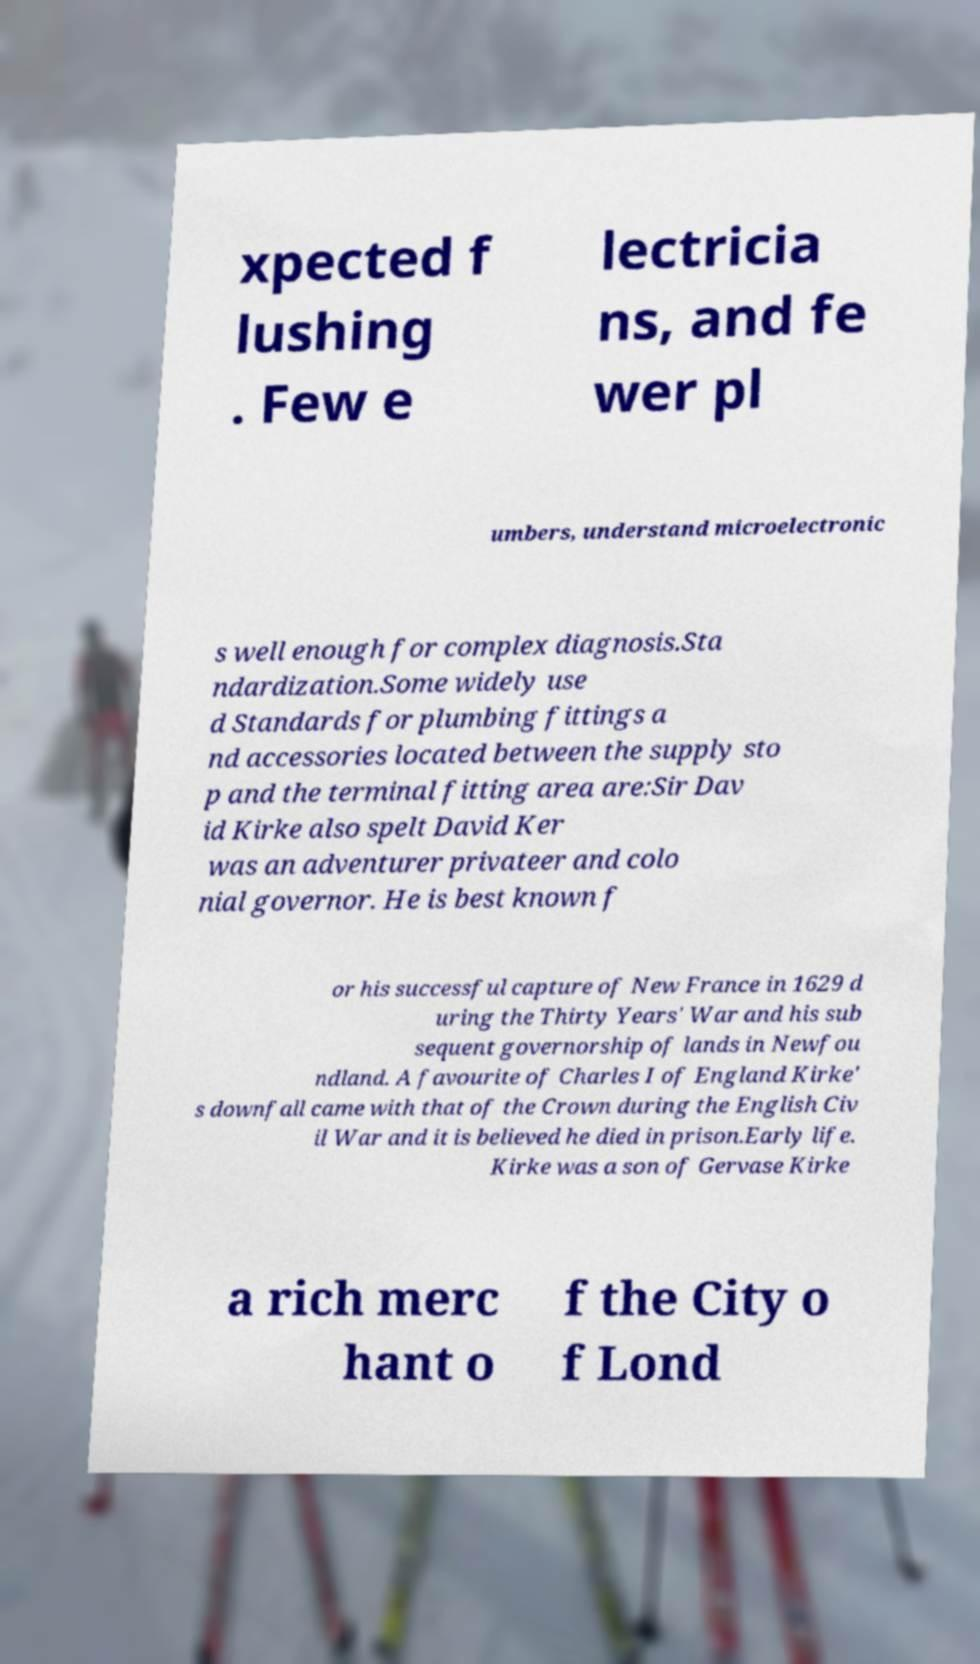Could you extract and type out the text from this image? xpected f lushing . Few e lectricia ns, and fe wer pl umbers, understand microelectronic s well enough for complex diagnosis.Sta ndardization.Some widely use d Standards for plumbing fittings a nd accessories located between the supply sto p and the terminal fitting area are:Sir Dav id Kirke also spelt David Ker was an adventurer privateer and colo nial governor. He is best known f or his successful capture of New France in 1629 d uring the Thirty Years' War and his sub sequent governorship of lands in Newfou ndland. A favourite of Charles I of England Kirke' s downfall came with that of the Crown during the English Civ il War and it is believed he died in prison.Early life. Kirke was a son of Gervase Kirke a rich merc hant o f the City o f Lond 